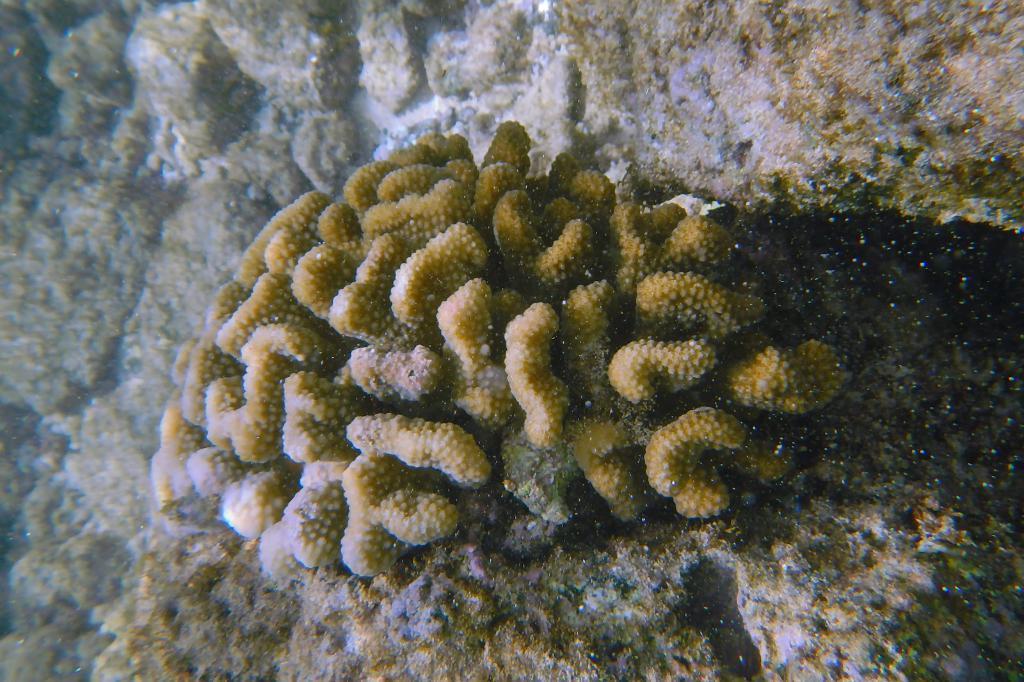Could you give a brief overview of what you see in this image? In this image there is underwater plants. 